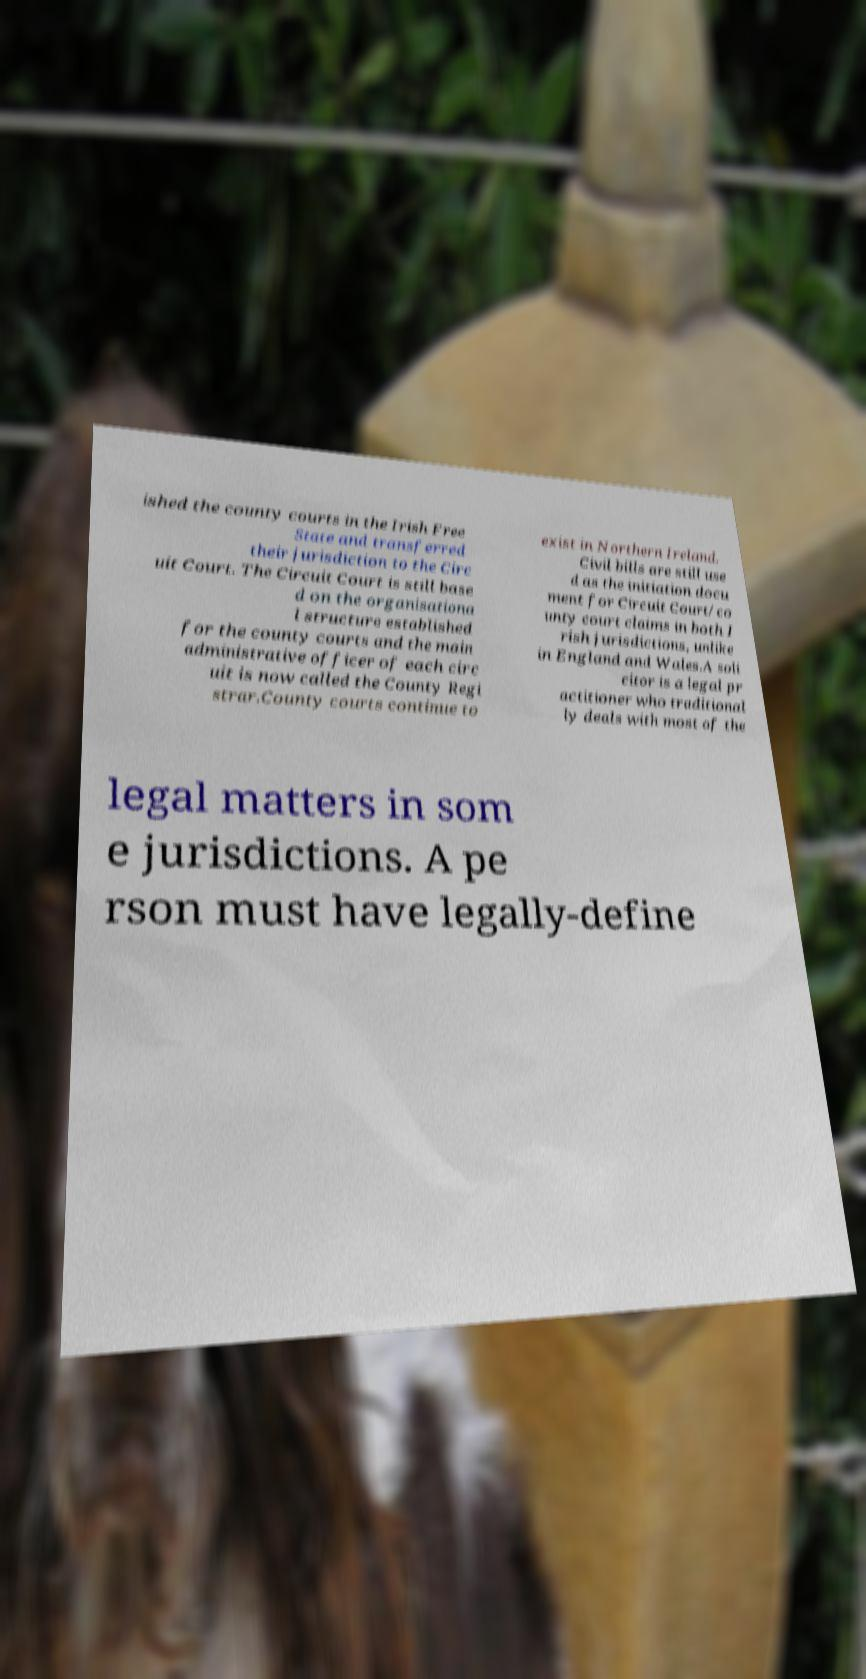Can you read and provide the text displayed in the image?This photo seems to have some interesting text. Can you extract and type it out for me? ished the county courts in the Irish Free State and transferred their jurisdiction to the Circ uit Court. The Circuit Court is still base d on the organisationa l structure established for the county courts and the main administrative officer of each circ uit is now called the County Regi strar.County courts continue to exist in Northern Ireland. Civil bills are still use d as the initiation docu ment for Circuit Court/co unty court claims in both I rish jurisdictions, unlike in England and Wales.A soli citor is a legal pr actitioner who traditional ly deals with most of the legal matters in som e jurisdictions. A pe rson must have legally-define 